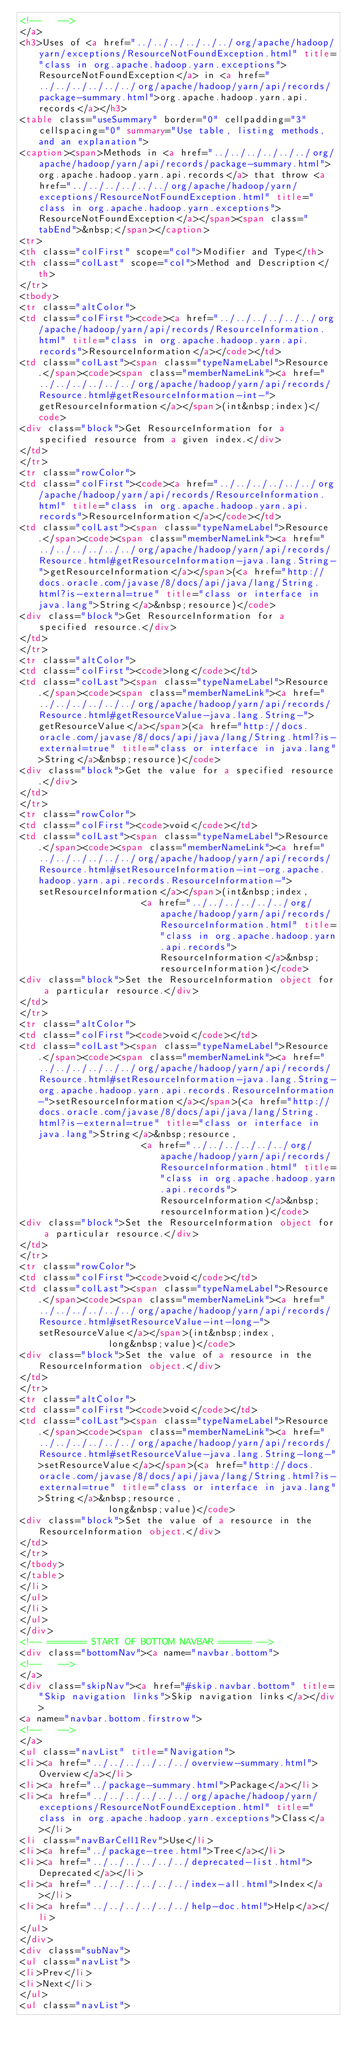<code> <loc_0><loc_0><loc_500><loc_500><_HTML_><!--   -->
</a>
<h3>Uses of <a href="../../../../../../org/apache/hadoop/yarn/exceptions/ResourceNotFoundException.html" title="class in org.apache.hadoop.yarn.exceptions">ResourceNotFoundException</a> in <a href="../../../../../../org/apache/hadoop/yarn/api/records/package-summary.html">org.apache.hadoop.yarn.api.records</a></h3>
<table class="useSummary" border="0" cellpadding="3" cellspacing="0" summary="Use table, listing methods, and an explanation">
<caption><span>Methods in <a href="../../../../../../org/apache/hadoop/yarn/api/records/package-summary.html">org.apache.hadoop.yarn.api.records</a> that throw <a href="../../../../../../org/apache/hadoop/yarn/exceptions/ResourceNotFoundException.html" title="class in org.apache.hadoop.yarn.exceptions">ResourceNotFoundException</a></span><span class="tabEnd">&nbsp;</span></caption>
<tr>
<th class="colFirst" scope="col">Modifier and Type</th>
<th class="colLast" scope="col">Method and Description</th>
</tr>
<tbody>
<tr class="altColor">
<td class="colFirst"><code><a href="../../../../../../org/apache/hadoop/yarn/api/records/ResourceInformation.html" title="class in org.apache.hadoop.yarn.api.records">ResourceInformation</a></code></td>
<td class="colLast"><span class="typeNameLabel">Resource.</span><code><span class="memberNameLink"><a href="../../../../../../org/apache/hadoop/yarn/api/records/Resource.html#getResourceInformation-int-">getResourceInformation</a></span>(int&nbsp;index)</code>
<div class="block">Get ResourceInformation for a specified resource from a given index.</div>
</td>
</tr>
<tr class="rowColor">
<td class="colFirst"><code><a href="../../../../../../org/apache/hadoop/yarn/api/records/ResourceInformation.html" title="class in org.apache.hadoop.yarn.api.records">ResourceInformation</a></code></td>
<td class="colLast"><span class="typeNameLabel">Resource.</span><code><span class="memberNameLink"><a href="../../../../../../org/apache/hadoop/yarn/api/records/Resource.html#getResourceInformation-java.lang.String-">getResourceInformation</a></span>(<a href="http://docs.oracle.com/javase/8/docs/api/java/lang/String.html?is-external=true" title="class or interface in java.lang">String</a>&nbsp;resource)</code>
<div class="block">Get ResourceInformation for a specified resource.</div>
</td>
</tr>
<tr class="altColor">
<td class="colFirst"><code>long</code></td>
<td class="colLast"><span class="typeNameLabel">Resource.</span><code><span class="memberNameLink"><a href="../../../../../../org/apache/hadoop/yarn/api/records/Resource.html#getResourceValue-java.lang.String-">getResourceValue</a></span>(<a href="http://docs.oracle.com/javase/8/docs/api/java/lang/String.html?is-external=true" title="class or interface in java.lang">String</a>&nbsp;resource)</code>
<div class="block">Get the value for a specified resource.</div>
</td>
</tr>
<tr class="rowColor">
<td class="colFirst"><code>void</code></td>
<td class="colLast"><span class="typeNameLabel">Resource.</span><code><span class="memberNameLink"><a href="../../../../../../org/apache/hadoop/yarn/api/records/Resource.html#setResourceInformation-int-org.apache.hadoop.yarn.api.records.ResourceInformation-">setResourceInformation</a></span>(int&nbsp;index,
                      <a href="../../../../../../org/apache/hadoop/yarn/api/records/ResourceInformation.html" title="class in org.apache.hadoop.yarn.api.records">ResourceInformation</a>&nbsp;resourceInformation)</code>
<div class="block">Set the ResourceInformation object for a particular resource.</div>
</td>
</tr>
<tr class="altColor">
<td class="colFirst"><code>void</code></td>
<td class="colLast"><span class="typeNameLabel">Resource.</span><code><span class="memberNameLink"><a href="../../../../../../org/apache/hadoop/yarn/api/records/Resource.html#setResourceInformation-java.lang.String-org.apache.hadoop.yarn.api.records.ResourceInformation-">setResourceInformation</a></span>(<a href="http://docs.oracle.com/javase/8/docs/api/java/lang/String.html?is-external=true" title="class or interface in java.lang">String</a>&nbsp;resource,
                      <a href="../../../../../../org/apache/hadoop/yarn/api/records/ResourceInformation.html" title="class in org.apache.hadoop.yarn.api.records">ResourceInformation</a>&nbsp;resourceInformation)</code>
<div class="block">Set the ResourceInformation object for a particular resource.</div>
</td>
</tr>
<tr class="rowColor">
<td class="colFirst"><code>void</code></td>
<td class="colLast"><span class="typeNameLabel">Resource.</span><code><span class="memberNameLink"><a href="../../../../../../org/apache/hadoop/yarn/api/records/Resource.html#setResourceValue-int-long-">setResourceValue</a></span>(int&nbsp;index,
                long&nbsp;value)</code>
<div class="block">Set the value of a resource in the ResourceInformation object.</div>
</td>
</tr>
<tr class="altColor">
<td class="colFirst"><code>void</code></td>
<td class="colLast"><span class="typeNameLabel">Resource.</span><code><span class="memberNameLink"><a href="../../../../../../org/apache/hadoop/yarn/api/records/Resource.html#setResourceValue-java.lang.String-long-">setResourceValue</a></span>(<a href="http://docs.oracle.com/javase/8/docs/api/java/lang/String.html?is-external=true" title="class or interface in java.lang">String</a>&nbsp;resource,
                long&nbsp;value)</code>
<div class="block">Set the value of a resource in the ResourceInformation object.</div>
</td>
</tr>
</tbody>
</table>
</li>
</ul>
</li>
</ul>
</div>
<!-- ======= START OF BOTTOM NAVBAR ====== -->
<div class="bottomNav"><a name="navbar.bottom">
<!--   -->
</a>
<div class="skipNav"><a href="#skip.navbar.bottom" title="Skip navigation links">Skip navigation links</a></div>
<a name="navbar.bottom.firstrow">
<!--   -->
</a>
<ul class="navList" title="Navigation">
<li><a href="../../../../../../overview-summary.html">Overview</a></li>
<li><a href="../package-summary.html">Package</a></li>
<li><a href="../../../../../../org/apache/hadoop/yarn/exceptions/ResourceNotFoundException.html" title="class in org.apache.hadoop.yarn.exceptions">Class</a></li>
<li class="navBarCell1Rev">Use</li>
<li><a href="../package-tree.html">Tree</a></li>
<li><a href="../../../../../../deprecated-list.html">Deprecated</a></li>
<li><a href="../../../../../../index-all.html">Index</a></li>
<li><a href="../../../../../../help-doc.html">Help</a></li>
</ul>
</div>
<div class="subNav">
<ul class="navList">
<li>Prev</li>
<li>Next</li>
</ul>
<ul class="navList"></code> 